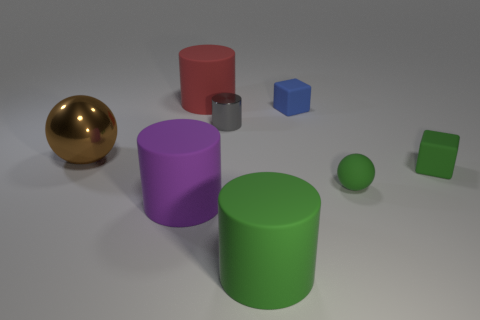Are there more rubber cubes than cylinders?
Your answer should be very brief. No. Do the small blue object and the tiny gray thing have the same shape?
Provide a short and direct response. No. Are there any other things that are the same shape as the blue matte thing?
Provide a succinct answer. Yes. There is a small block to the left of the green matte cube; does it have the same color as the ball in front of the brown object?
Ensure brevity in your answer.  No. Are there fewer green cubes on the left side of the small blue thing than large matte cylinders that are right of the tiny gray shiny thing?
Your answer should be very brief. Yes. The tiny rubber thing behind the brown sphere has what shape?
Make the answer very short. Cube. What number of other things are the same material as the red cylinder?
Provide a succinct answer. 5. There is a gray shiny object; does it have the same shape as the matte object that is in front of the big purple matte object?
Provide a succinct answer. Yes. There is a big purple thing that is made of the same material as the tiny green block; what is its shape?
Offer a terse response. Cylinder. Are there more objects right of the brown metal sphere than red rubber cylinders that are in front of the tiny blue matte cube?
Give a very brief answer. Yes. 